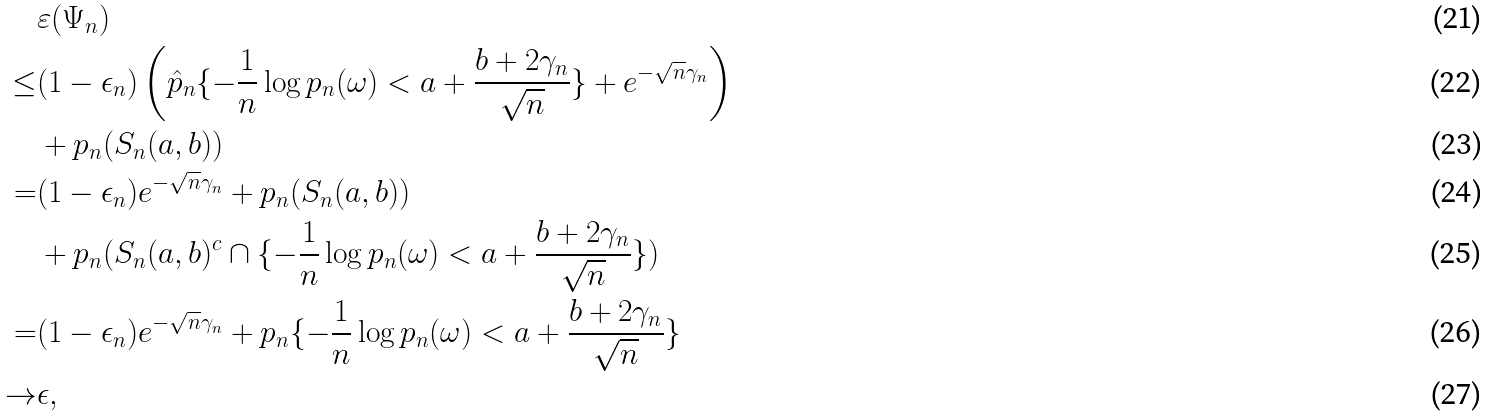Convert formula to latex. <formula><loc_0><loc_0><loc_500><loc_500>& \varepsilon ( \Psi _ { n } ) \\ \leq & ( 1 - \epsilon _ { n } ) \left ( \hat { p } _ { n } \{ - \frac { 1 } { n } \log p _ { n } ( \omega ) < a + \frac { b + 2 \gamma _ { n } } { \sqrt { n } } \} + e ^ { - \sqrt { n } \gamma _ { n } } \right ) \\ & + p _ { n } ( S _ { n } ( a , b ) ) \\ = & ( 1 - \epsilon _ { n } ) e ^ { - \sqrt { n } \gamma _ { n } } + p _ { n } ( S _ { n } ( a , b ) ) \\ & + p _ { n } ( S _ { n } ( a , b ) ^ { c } \cap \{ - \frac { 1 } { n } \log p _ { n } ( \omega ) < a + \frac { b + 2 \gamma _ { n } } { \sqrt { n } } \} ) \\ = & ( 1 - \epsilon _ { n } ) e ^ { - \sqrt { n } \gamma _ { n } } + p _ { n } \{ - \frac { 1 } { n } \log p _ { n } ( \omega ) < a + \frac { b + 2 \gamma _ { n } } { \sqrt { n } } \} \\ \to & \epsilon ,</formula> 